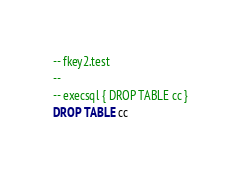Convert code to text. <code><loc_0><loc_0><loc_500><loc_500><_SQL_>-- fkey2.test
-- 
-- execsql { DROP TABLE cc }
DROP TABLE cc</code> 